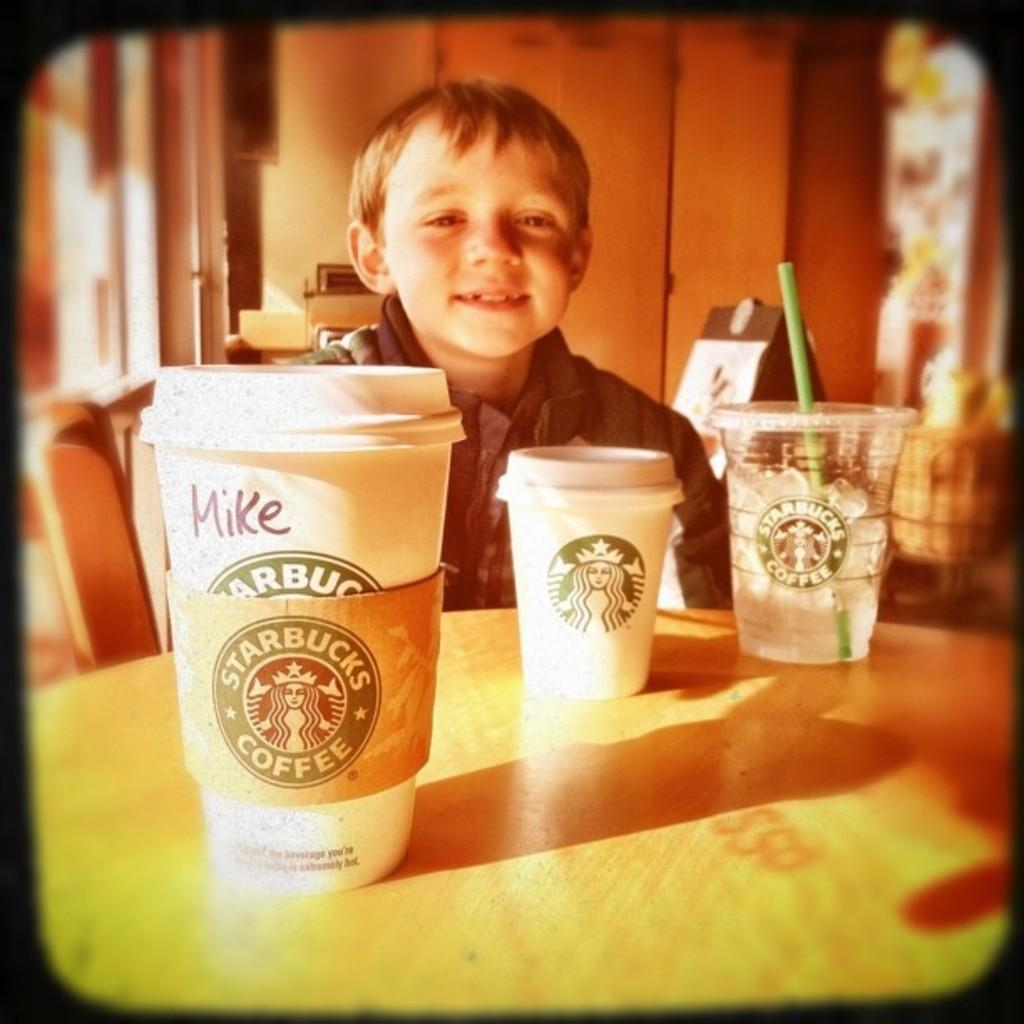<image>
Share a concise interpretation of the image provided. A child who may or may not be Mike sits at a table with three Starbucks beverages. 